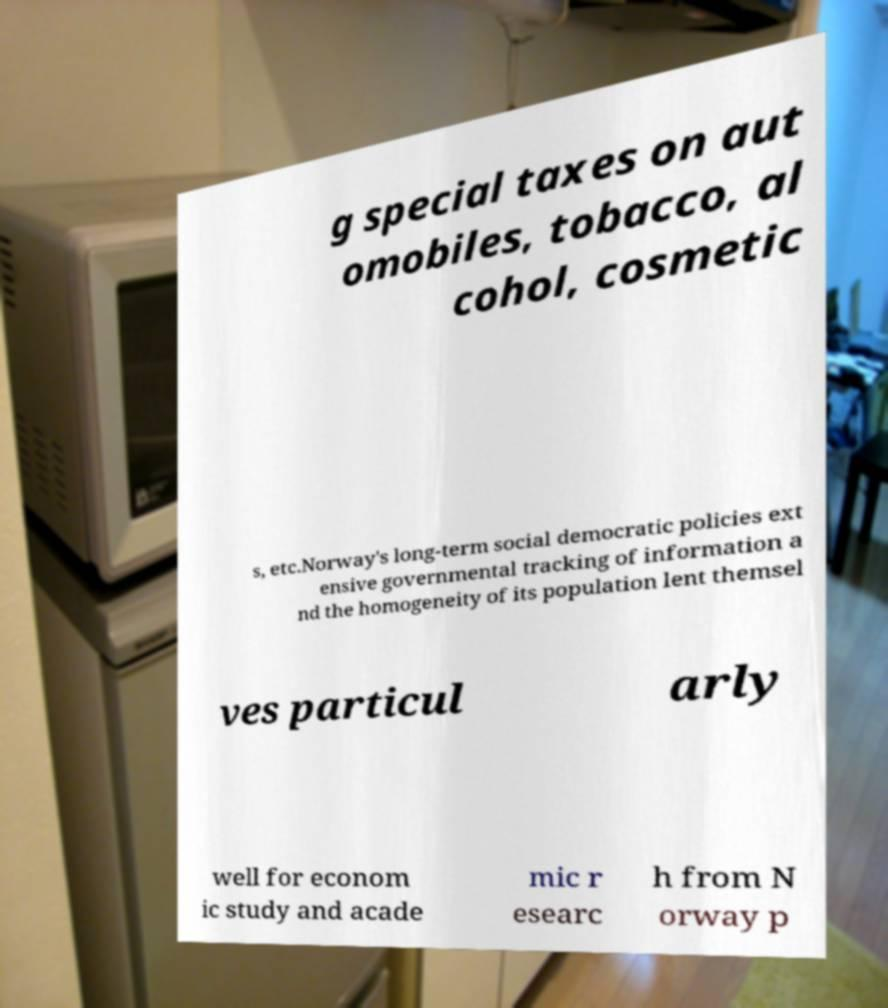There's text embedded in this image that I need extracted. Can you transcribe it verbatim? g special taxes on aut omobiles, tobacco, al cohol, cosmetic s, etc.Norway's long-term social democratic policies ext ensive governmental tracking of information a nd the homogeneity of its population lent themsel ves particul arly well for econom ic study and acade mic r esearc h from N orway p 